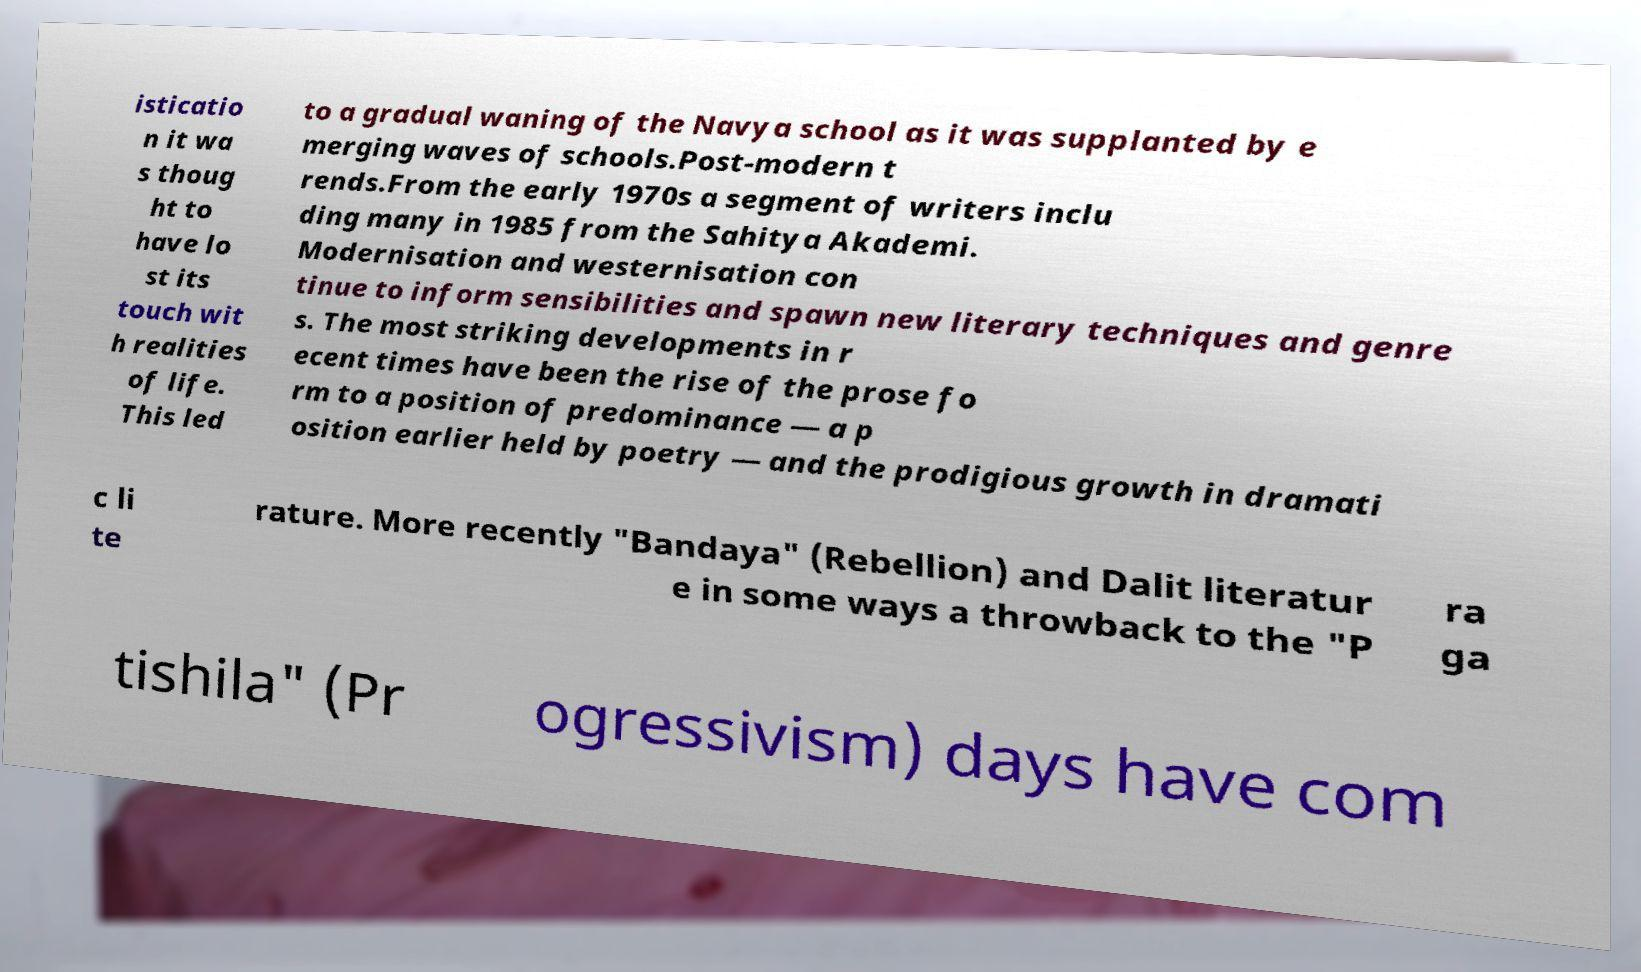Could you extract and type out the text from this image? isticatio n it wa s thoug ht to have lo st its touch wit h realities of life. This led to a gradual waning of the Navya school as it was supplanted by e merging waves of schools.Post-modern t rends.From the early 1970s a segment of writers inclu ding many in 1985 from the Sahitya Akademi. Modernisation and westernisation con tinue to inform sensibilities and spawn new literary techniques and genre s. The most striking developments in r ecent times have been the rise of the prose fo rm to a position of predominance — a p osition earlier held by poetry — and the prodigious growth in dramati c li te rature. More recently "Bandaya" (Rebellion) and Dalit literatur e in some ways a throwback to the "P ra ga tishila" (Pr ogressivism) days have com 